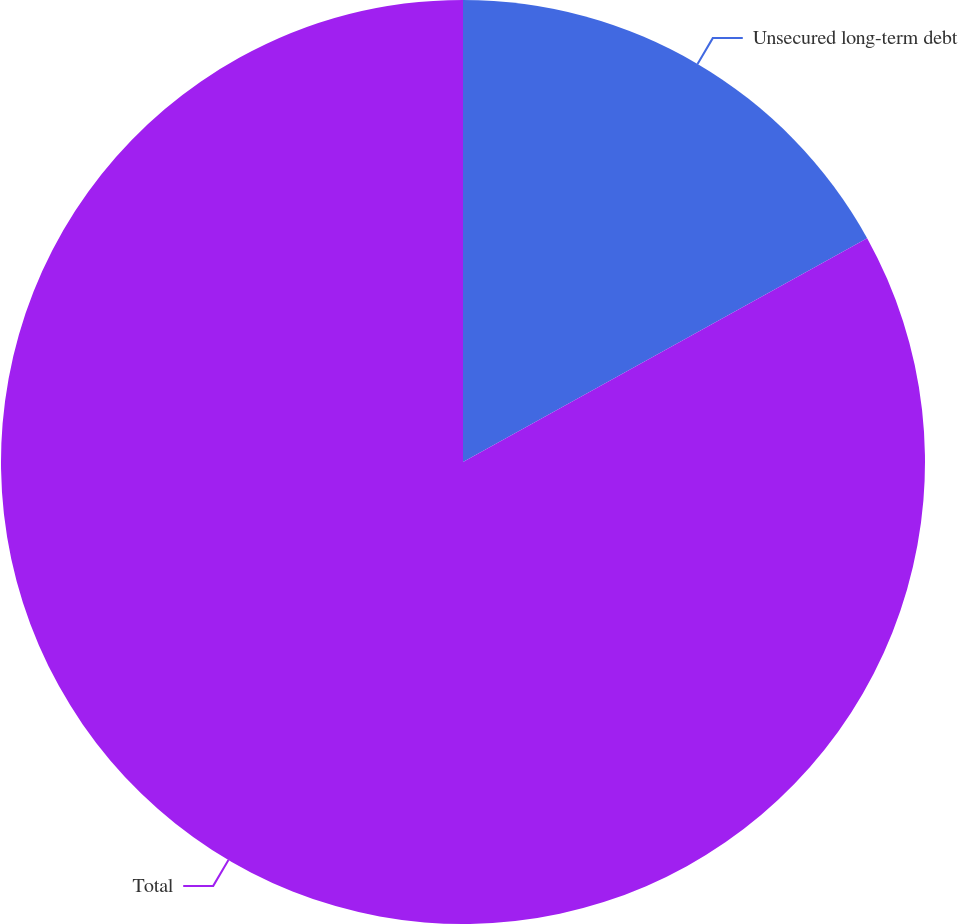<chart> <loc_0><loc_0><loc_500><loc_500><pie_chart><fcel>Unsecured long-term debt<fcel>Total<nl><fcel>16.95%<fcel>83.05%<nl></chart> 